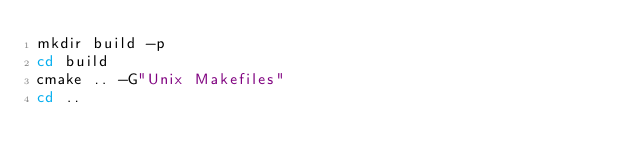<code> <loc_0><loc_0><loc_500><loc_500><_Bash_>mkdir build -p
cd build
cmake .. -G"Unix Makefiles"
cd ..
</code> 